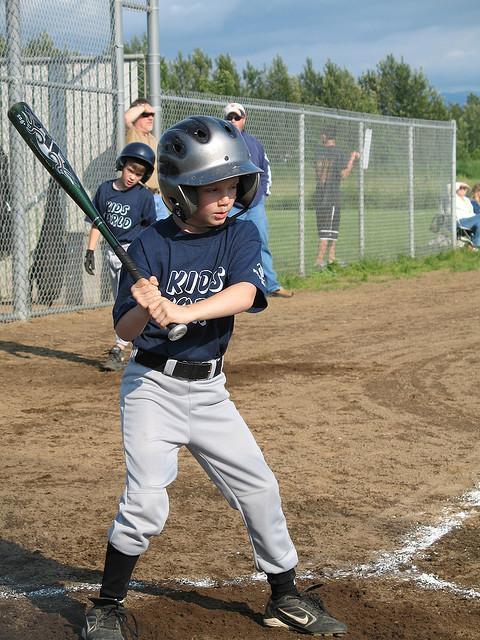How many people are there?
Give a very brief answer. 4. 